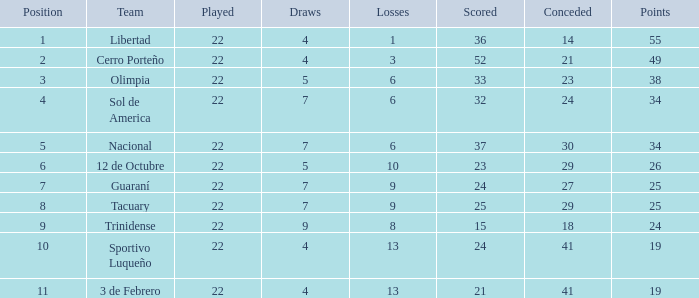What is the value scored when there were 19 points for the team 3 de Febrero? 21.0. 